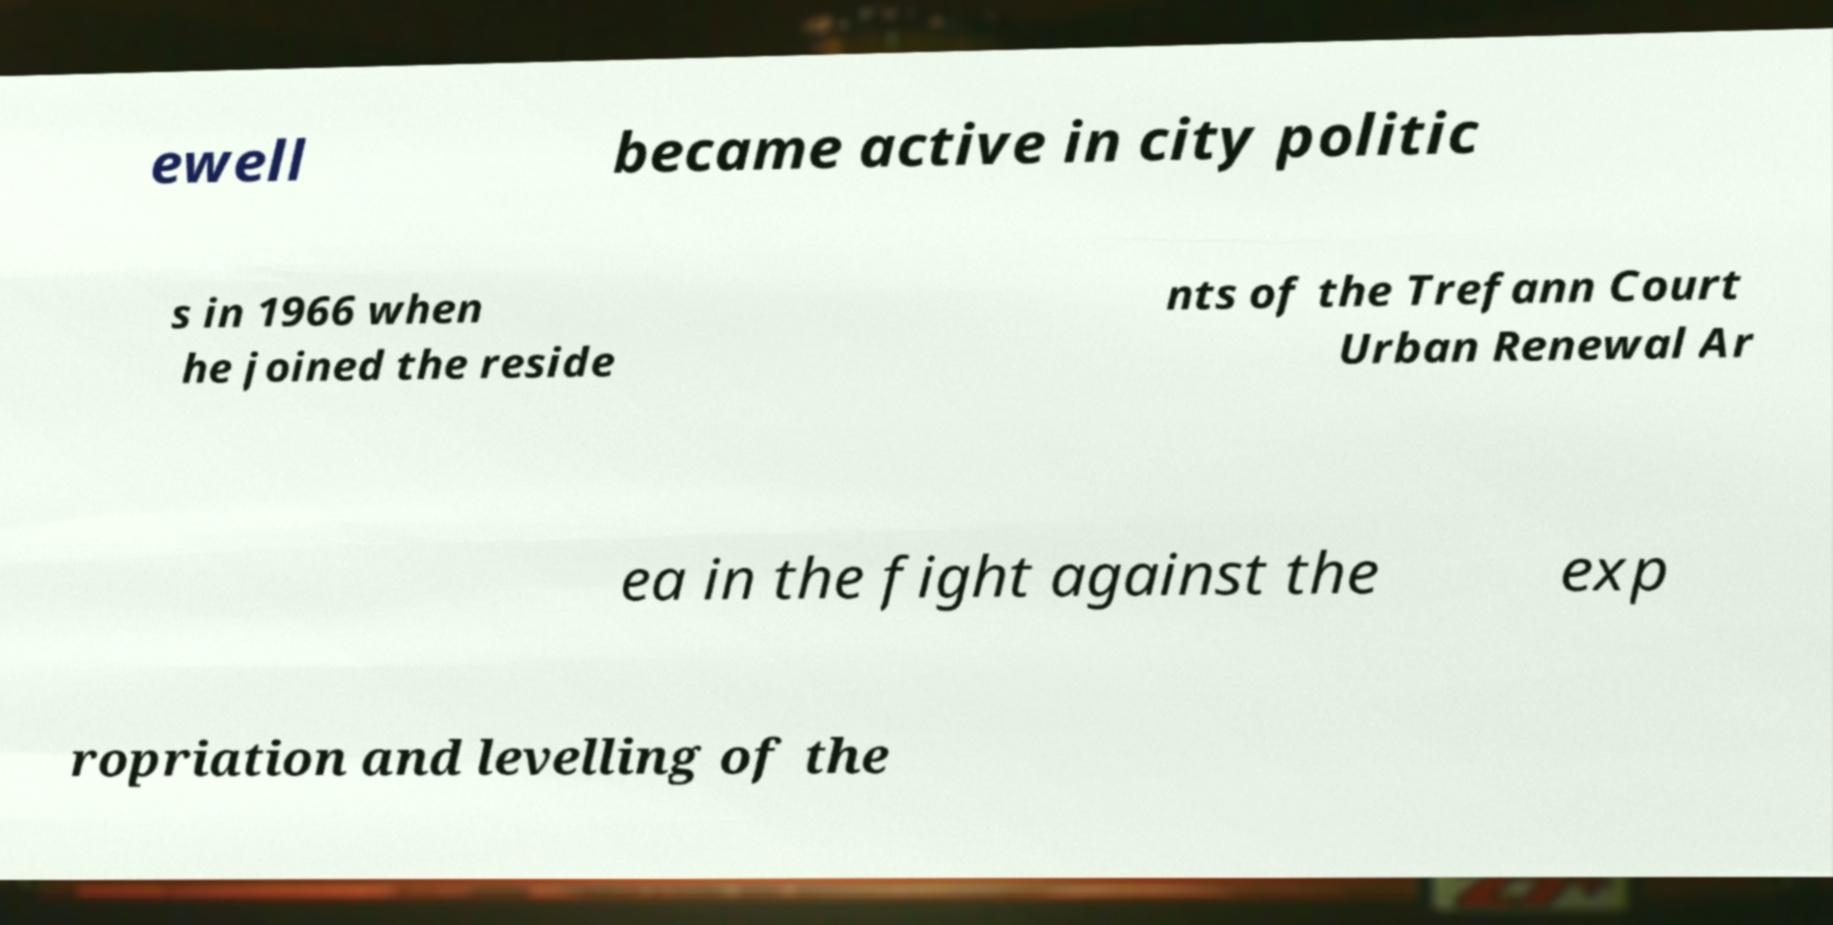Could you assist in decoding the text presented in this image and type it out clearly? ewell became active in city politic s in 1966 when he joined the reside nts of the Trefann Court Urban Renewal Ar ea in the fight against the exp ropriation and levelling of the 